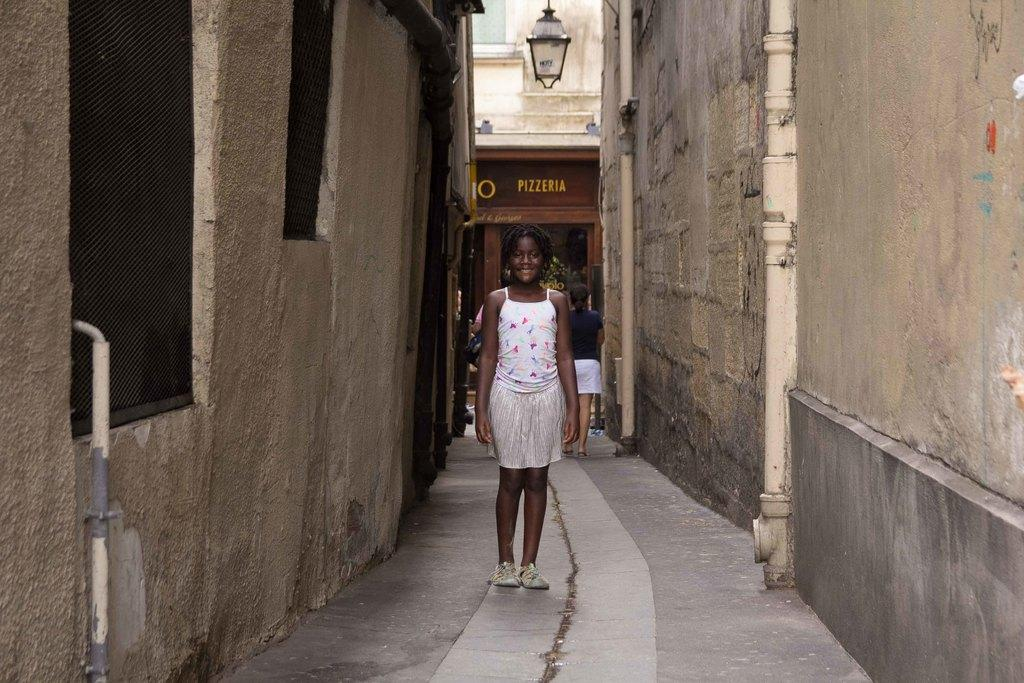What is the main focus of the image? The main focus of the image is the people in the center. What can be seen in the distance behind the people? There are buildings in the background of the image. What object is visible in the image? There is a board visible in the image. What type of toe is being tickled in the image? There is no toe present in the image, so it cannot be tickled. 